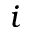Convert formula to latex. <formula><loc_0><loc_0><loc_500><loc_500>i</formula> 